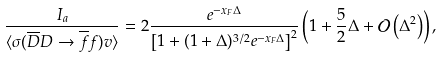<formula> <loc_0><loc_0><loc_500><loc_500>\frac { I _ { a } } { \langle \sigma ( \overline { D } D \rightarrow \overline { f } f ) v \rangle } = 2 \frac { e ^ { - x _ { F } \Delta } } { \left [ 1 + ( 1 + \Delta ) ^ { 3 / 2 } e ^ { - x _ { F } \Delta } \right ] ^ { 2 } } \left ( 1 + \frac { 5 } { 2 } \Delta + \mathcal { O } \left ( \Delta ^ { 2 } \right ) \right ) ,</formula> 